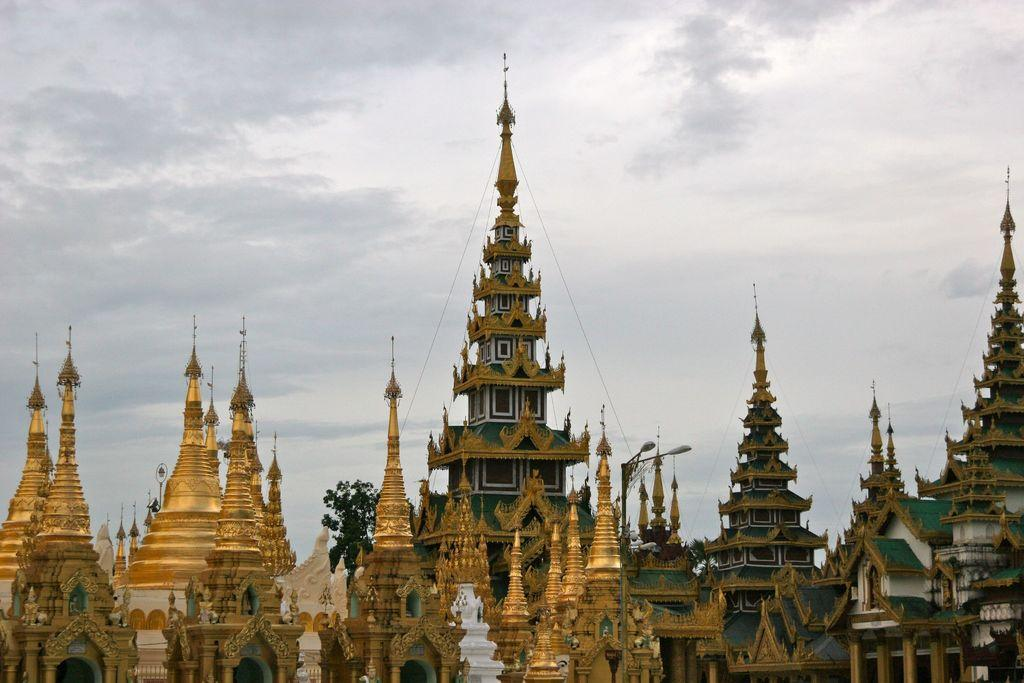What can be seen in the image? There are many buildings in the image. What colors are the buildings? The buildings are in green and gold color. What other objects can be seen in the background of the image? There are light poles and trees in green color in the background. How would you describe the sky in the image? The sky is white and gray in color. Can you see a bat flying near the buildings in the image? There is no bat visible in the image; it only features buildings, light poles, trees, and the sky. 